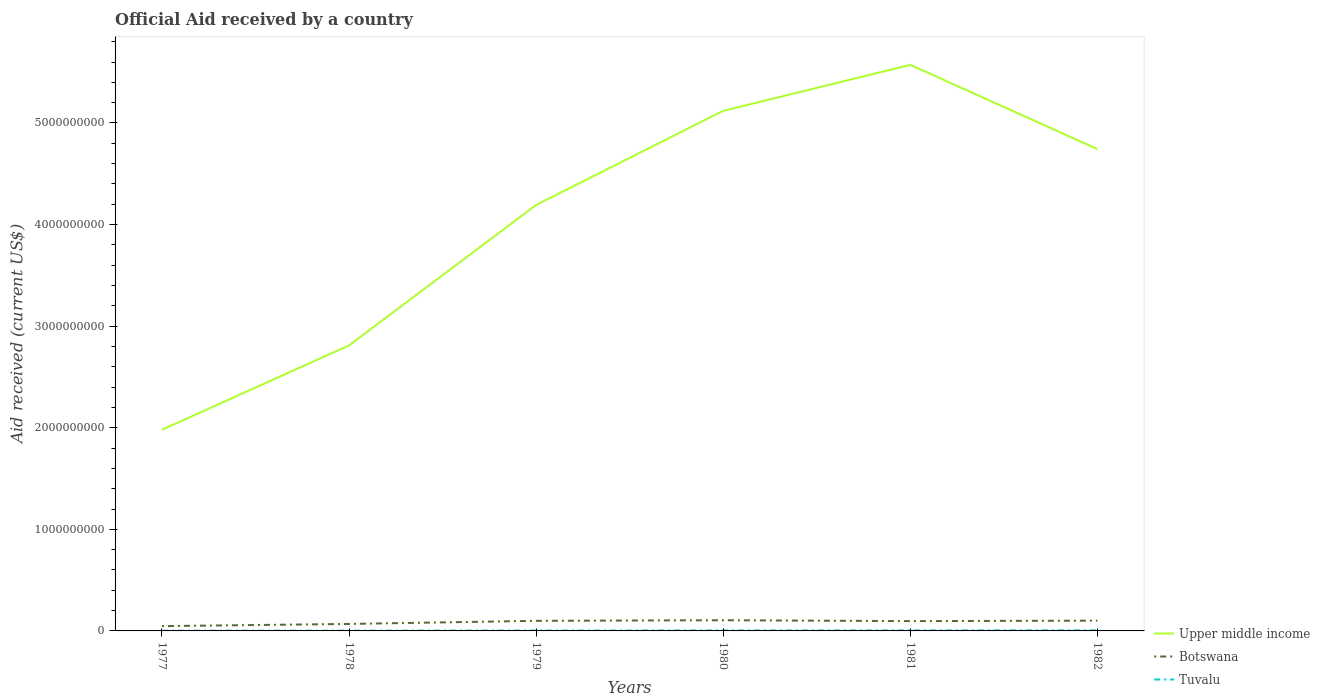How many different coloured lines are there?
Make the answer very short. 3. Does the line corresponding to Tuvalu intersect with the line corresponding to Botswana?
Offer a terse response. No. Is the number of lines equal to the number of legend labels?
Ensure brevity in your answer.  Yes. Across all years, what is the maximum net official aid received in Upper middle income?
Offer a very short reply. 1.98e+09. In which year was the net official aid received in Botswana maximum?
Your response must be concise. 1977. What is the total net official aid received in Tuvalu in the graph?
Ensure brevity in your answer.  -8.10e+05. What is the difference between the highest and the second highest net official aid received in Botswana?
Make the answer very short. 5.80e+07. What is the difference between the highest and the lowest net official aid received in Botswana?
Your response must be concise. 4. What is the difference between two consecutive major ticks on the Y-axis?
Your response must be concise. 1.00e+09. Are the values on the major ticks of Y-axis written in scientific E-notation?
Your response must be concise. No. Does the graph contain grids?
Provide a short and direct response. No. How are the legend labels stacked?
Keep it short and to the point. Vertical. What is the title of the graph?
Keep it short and to the point. Official Aid received by a country. Does "El Salvador" appear as one of the legend labels in the graph?
Your answer should be compact. No. What is the label or title of the X-axis?
Ensure brevity in your answer.  Years. What is the label or title of the Y-axis?
Provide a succinct answer. Aid received (current US$). What is the Aid received (current US$) of Upper middle income in 1977?
Offer a terse response. 1.98e+09. What is the Aid received (current US$) of Botswana in 1977?
Ensure brevity in your answer.  4.72e+07. What is the Aid received (current US$) in Tuvalu in 1977?
Offer a very short reply. 2.38e+06. What is the Aid received (current US$) in Upper middle income in 1978?
Provide a succinct answer. 2.81e+09. What is the Aid received (current US$) in Botswana in 1978?
Your answer should be very brief. 6.88e+07. What is the Aid received (current US$) in Tuvalu in 1978?
Your answer should be compact. 2.85e+06. What is the Aid received (current US$) of Upper middle income in 1979?
Provide a succinct answer. 4.19e+09. What is the Aid received (current US$) in Botswana in 1979?
Offer a very short reply. 9.94e+07. What is the Aid received (current US$) of Tuvalu in 1979?
Provide a short and direct response. 4.10e+06. What is the Aid received (current US$) in Upper middle income in 1980?
Ensure brevity in your answer.  5.12e+09. What is the Aid received (current US$) of Botswana in 1980?
Your response must be concise. 1.05e+08. What is the Aid received (current US$) in Tuvalu in 1980?
Provide a short and direct response. 4.91e+06. What is the Aid received (current US$) in Upper middle income in 1981?
Offer a very short reply. 5.57e+09. What is the Aid received (current US$) in Botswana in 1981?
Make the answer very short. 9.65e+07. What is the Aid received (current US$) of Tuvalu in 1981?
Your answer should be compact. 5.35e+06. What is the Aid received (current US$) of Upper middle income in 1982?
Your answer should be compact. 4.74e+09. What is the Aid received (current US$) of Botswana in 1982?
Provide a succinct answer. 1.01e+08. What is the Aid received (current US$) of Tuvalu in 1982?
Ensure brevity in your answer.  6.23e+06. Across all years, what is the maximum Aid received (current US$) of Upper middle income?
Your response must be concise. 5.57e+09. Across all years, what is the maximum Aid received (current US$) in Botswana?
Give a very brief answer. 1.05e+08. Across all years, what is the maximum Aid received (current US$) in Tuvalu?
Offer a very short reply. 6.23e+06. Across all years, what is the minimum Aid received (current US$) of Upper middle income?
Offer a terse response. 1.98e+09. Across all years, what is the minimum Aid received (current US$) in Botswana?
Offer a terse response. 4.72e+07. Across all years, what is the minimum Aid received (current US$) in Tuvalu?
Your answer should be compact. 2.38e+06. What is the total Aid received (current US$) of Upper middle income in the graph?
Your answer should be compact. 2.44e+1. What is the total Aid received (current US$) of Botswana in the graph?
Your answer should be compact. 5.18e+08. What is the total Aid received (current US$) of Tuvalu in the graph?
Provide a short and direct response. 2.58e+07. What is the difference between the Aid received (current US$) of Upper middle income in 1977 and that in 1978?
Offer a very short reply. -8.31e+08. What is the difference between the Aid received (current US$) in Botswana in 1977 and that in 1978?
Keep it short and to the point. -2.15e+07. What is the difference between the Aid received (current US$) of Tuvalu in 1977 and that in 1978?
Ensure brevity in your answer.  -4.70e+05. What is the difference between the Aid received (current US$) in Upper middle income in 1977 and that in 1979?
Your response must be concise. -2.21e+09. What is the difference between the Aid received (current US$) in Botswana in 1977 and that in 1979?
Keep it short and to the point. -5.22e+07. What is the difference between the Aid received (current US$) of Tuvalu in 1977 and that in 1979?
Provide a succinct answer. -1.72e+06. What is the difference between the Aid received (current US$) of Upper middle income in 1977 and that in 1980?
Your answer should be compact. -3.14e+09. What is the difference between the Aid received (current US$) of Botswana in 1977 and that in 1980?
Ensure brevity in your answer.  -5.80e+07. What is the difference between the Aid received (current US$) of Tuvalu in 1977 and that in 1980?
Ensure brevity in your answer.  -2.53e+06. What is the difference between the Aid received (current US$) of Upper middle income in 1977 and that in 1981?
Offer a terse response. -3.59e+09. What is the difference between the Aid received (current US$) in Botswana in 1977 and that in 1981?
Provide a short and direct response. -4.92e+07. What is the difference between the Aid received (current US$) in Tuvalu in 1977 and that in 1981?
Make the answer very short. -2.97e+06. What is the difference between the Aid received (current US$) of Upper middle income in 1977 and that in 1982?
Give a very brief answer. -2.76e+09. What is the difference between the Aid received (current US$) of Botswana in 1977 and that in 1982?
Offer a very short reply. -5.39e+07. What is the difference between the Aid received (current US$) of Tuvalu in 1977 and that in 1982?
Provide a succinct answer. -3.85e+06. What is the difference between the Aid received (current US$) of Upper middle income in 1978 and that in 1979?
Keep it short and to the point. -1.38e+09. What is the difference between the Aid received (current US$) in Botswana in 1978 and that in 1979?
Keep it short and to the point. -3.06e+07. What is the difference between the Aid received (current US$) in Tuvalu in 1978 and that in 1979?
Your answer should be very brief. -1.25e+06. What is the difference between the Aid received (current US$) of Upper middle income in 1978 and that in 1980?
Keep it short and to the point. -2.31e+09. What is the difference between the Aid received (current US$) in Botswana in 1978 and that in 1980?
Your answer should be very brief. -3.65e+07. What is the difference between the Aid received (current US$) of Tuvalu in 1978 and that in 1980?
Your answer should be compact. -2.06e+06. What is the difference between the Aid received (current US$) of Upper middle income in 1978 and that in 1981?
Provide a short and direct response. -2.76e+09. What is the difference between the Aid received (current US$) in Botswana in 1978 and that in 1981?
Keep it short and to the point. -2.77e+07. What is the difference between the Aid received (current US$) in Tuvalu in 1978 and that in 1981?
Offer a very short reply. -2.50e+06. What is the difference between the Aid received (current US$) of Upper middle income in 1978 and that in 1982?
Give a very brief answer. -1.93e+09. What is the difference between the Aid received (current US$) in Botswana in 1978 and that in 1982?
Keep it short and to the point. -3.24e+07. What is the difference between the Aid received (current US$) of Tuvalu in 1978 and that in 1982?
Your response must be concise. -3.38e+06. What is the difference between the Aid received (current US$) in Upper middle income in 1979 and that in 1980?
Offer a very short reply. -9.26e+08. What is the difference between the Aid received (current US$) of Botswana in 1979 and that in 1980?
Ensure brevity in your answer.  -5.86e+06. What is the difference between the Aid received (current US$) in Tuvalu in 1979 and that in 1980?
Offer a terse response. -8.10e+05. What is the difference between the Aid received (current US$) of Upper middle income in 1979 and that in 1981?
Keep it short and to the point. -1.38e+09. What is the difference between the Aid received (current US$) of Botswana in 1979 and that in 1981?
Your answer should be compact. 2.94e+06. What is the difference between the Aid received (current US$) in Tuvalu in 1979 and that in 1981?
Your response must be concise. -1.25e+06. What is the difference between the Aid received (current US$) of Upper middle income in 1979 and that in 1982?
Provide a short and direct response. -5.50e+08. What is the difference between the Aid received (current US$) of Botswana in 1979 and that in 1982?
Keep it short and to the point. -1.73e+06. What is the difference between the Aid received (current US$) in Tuvalu in 1979 and that in 1982?
Make the answer very short. -2.13e+06. What is the difference between the Aid received (current US$) in Upper middle income in 1980 and that in 1981?
Ensure brevity in your answer.  -4.53e+08. What is the difference between the Aid received (current US$) of Botswana in 1980 and that in 1981?
Make the answer very short. 8.80e+06. What is the difference between the Aid received (current US$) in Tuvalu in 1980 and that in 1981?
Your answer should be compact. -4.40e+05. What is the difference between the Aid received (current US$) of Upper middle income in 1980 and that in 1982?
Your response must be concise. 3.76e+08. What is the difference between the Aid received (current US$) of Botswana in 1980 and that in 1982?
Your response must be concise. 4.13e+06. What is the difference between the Aid received (current US$) of Tuvalu in 1980 and that in 1982?
Offer a terse response. -1.32e+06. What is the difference between the Aid received (current US$) in Upper middle income in 1981 and that in 1982?
Give a very brief answer. 8.29e+08. What is the difference between the Aid received (current US$) of Botswana in 1981 and that in 1982?
Keep it short and to the point. -4.67e+06. What is the difference between the Aid received (current US$) in Tuvalu in 1981 and that in 1982?
Keep it short and to the point. -8.80e+05. What is the difference between the Aid received (current US$) of Upper middle income in 1977 and the Aid received (current US$) of Botswana in 1978?
Ensure brevity in your answer.  1.91e+09. What is the difference between the Aid received (current US$) in Upper middle income in 1977 and the Aid received (current US$) in Tuvalu in 1978?
Provide a succinct answer. 1.98e+09. What is the difference between the Aid received (current US$) of Botswana in 1977 and the Aid received (current US$) of Tuvalu in 1978?
Your answer should be very brief. 4.44e+07. What is the difference between the Aid received (current US$) in Upper middle income in 1977 and the Aid received (current US$) in Botswana in 1979?
Offer a terse response. 1.88e+09. What is the difference between the Aid received (current US$) in Upper middle income in 1977 and the Aid received (current US$) in Tuvalu in 1979?
Provide a short and direct response. 1.98e+09. What is the difference between the Aid received (current US$) of Botswana in 1977 and the Aid received (current US$) of Tuvalu in 1979?
Give a very brief answer. 4.32e+07. What is the difference between the Aid received (current US$) in Upper middle income in 1977 and the Aid received (current US$) in Botswana in 1980?
Keep it short and to the point. 1.87e+09. What is the difference between the Aid received (current US$) in Upper middle income in 1977 and the Aid received (current US$) in Tuvalu in 1980?
Offer a very short reply. 1.98e+09. What is the difference between the Aid received (current US$) in Botswana in 1977 and the Aid received (current US$) in Tuvalu in 1980?
Your answer should be very brief. 4.23e+07. What is the difference between the Aid received (current US$) of Upper middle income in 1977 and the Aid received (current US$) of Botswana in 1981?
Make the answer very short. 1.88e+09. What is the difference between the Aid received (current US$) of Upper middle income in 1977 and the Aid received (current US$) of Tuvalu in 1981?
Make the answer very short. 1.97e+09. What is the difference between the Aid received (current US$) in Botswana in 1977 and the Aid received (current US$) in Tuvalu in 1981?
Provide a short and direct response. 4.19e+07. What is the difference between the Aid received (current US$) in Upper middle income in 1977 and the Aid received (current US$) in Botswana in 1982?
Ensure brevity in your answer.  1.88e+09. What is the difference between the Aid received (current US$) of Upper middle income in 1977 and the Aid received (current US$) of Tuvalu in 1982?
Offer a very short reply. 1.97e+09. What is the difference between the Aid received (current US$) of Botswana in 1977 and the Aid received (current US$) of Tuvalu in 1982?
Offer a terse response. 4.10e+07. What is the difference between the Aid received (current US$) of Upper middle income in 1978 and the Aid received (current US$) of Botswana in 1979?
Provide a succinct answer. 2.71e+09. What is the difference between the Aid received (current US$) of Upper middle income in 1978 and the Aid received (current US$) of Tuvalu in 1979?
Your answer should be compact. 2.81e+09. What is the difference between the Aid received (current US$) of Botswana in 1978 and the Aid received (current US$) of Tuvalu in 1979?
Ensure brevity in your answer.  6.47e+07. What is the difference between the Aid received (current US$) in Upper middle income in 1978 and the Aid received (current US$) in Botswana in 1980?
Make the answer very short. 2.71e+09. What is the difference between the Aid received (current US$) of Upper middle income in 1978 and the Aid received (current US$) of Tuvalu in 1980?
Provide a succinct answer. 2.81e+09. What is the difference between the Aid received (current US$) of Botswana in 1978 and the Aid received (current US$) of Tuvalu in 1980?
Keep it short and to the point. 6.39e+07. What is the difference between the Aid received (current US$) of Upper middle income in 1978 and the Aid received (current US$) of Botswana in 1981?
Make the answer very short. 2.71e+09. What is the difference between the Aid received (current US$) of Upper middle income in 1978 and the Aid received (current US$) of Tuvalu in 1981?
Provide a short and direct response. 2.81e+09. What is the difference between the Aid received (current US$) of Botswana in 1978 and the Aid received (current US$) of Tuvalu in 1981?
Your answer should be compact. 6.34e+07. What is the difference between the Aid received (current US$) in Upper middle income in 1978 and the Aid received (current US$) in Botswana in 1982?
Your answer should be compact. 2.71e+09. What is the difference between the Aid received (current US$) in Upper middle income in 1978 and the Aid received (current US$) in Tuvalu in 1982?
Your answer should be compact. 2.80e+09. What is the difference between the Aid received (current US$) in Botswana in 1978 and the Aid received (current US$) in Tuvalu in 1982?
Ensure brevity in your answer.  6.25e+07. What is the difference between the Aid received (current US$) in Upper middle income in 1979 and the Aid received (current US$) in Botswana in 1980?
Give a very brief answer. 4.09e+09. What is the difference between the Aid received (current US$) of Upper middle income in 1979 and the Aid received (current US$) of Tuvalu in 1980?
Your answer should be very brief. 4.19e+09. What is the difference between the Aid received (current US$) of Botswana in 1979 and the Aid received (current US$) of Tuvalu in 1980?
Your answer should be very brief. 9.45e+07. What is the difference between the Aid received (current US$) of Upper middle income in 1979 and the Aid received (current US$) of Botswana in 1981?
Offer a terse response. 4.10e+09. What is the difference between the Aid received (current US$) of Upper middle income in 1979 and the Aid received (current US$) of Tuvalu in 1981?
Provide a succinct answer. 4.19e+09. What is the difference between the Aid received (current US$) of Botswana in 1979 and the Aid received (current US$) of Tuvalu in 1981?
Provide a short and direct response. 9.41e+07. What is the difference between the Aid received (current US$) of Upper middle income in 1979 and the Aid received (current US$) of Botswana in 1982?
Provide a short and direct response. 4.09e+09. What is the difference between the Aid received (current US$) of Upper middle income in 1979 and the Aid received (current US$) of Tuvalu in 1982?
Keep it short and to the point. 4.19e+09. What is the difference between the Aid received (current US$) of Botswana in 1979 and the Aid received (current US$) of Tuvalu in 1982?
Your answer should be compact. 9.32e+07. What is the difference between the Aid received (current US$) of Upper middle income in 1980 and the Aid received (current US$) of Botswana in 1981?
Make the answer very short. 5.02e+09. What is the difference between the Aid received (current US$) of Upper middle income in 1980 and the Aid received (current US$) of Tuvalu in 1981?
Your answer should be very brief. 5.11e+09. What is the difference between the Aid received (current US$) of Botswana in 1980 and the Aid received (current US$) of Tuvalu in 1981?
Ensure brevity in your answer.  9.99e+07. What is the difference between the Aid received (current US$) in Upper middle income in 1980 and the Aid received (current US$) in Botswana in 1982?
Provide a short and direct response. 5.02e+09. What is the difference between the Aid received (current US$) in Upper middle income in 1980 and the Aid received (current US$) in Tuvalu in 1982?
Keep it short and to the point. 5.11e+09. What is the difference between the Aid received (current US$) in Botswana in 1980 and the Aid received (current US$) in Tuvalu in 1982?
Keep it short and to the point. 9.90e+07. What is the difference between the Aid received (current US$) of Upper middle income in 1981 and the Aid received (current US$) of Botswana in 1982?
Keep it short and to the point. 5.47e+09. What is the difference between the Aid received (current US$) of Upper middle income in 1981 and the Aid received (current US$) of Tuvalu in 1982?
Ensure brevity in your answer.  5.57e+09. What is the difference between the Aid received (current US$) of Botswana in 1981 and the Aid received (current US$) of Tuvalu in 1982?
Your answer should be compact. 9.02e+07. What is the average Aid received (current US$) in Upper middle income per year?
Make the answer very short. 4.07e+09. What is the average Aid received (current US$) of Botswana per year?
Give a very brief answer. 8.64e+07. What is the average Aid received (current US$) in Tuvalu per year?
Provide a succinct answer. 4.30e+06. In the year 1977, what is the difference between the Aid received (current US$) in Upper middle income and Aid received (current US$) in Botswana?
Give a very brief answer. 1.93e+09. In the year 1977, what is the difference between the Aid received (current US$) of Upper middle income and Aid received (current US$) of Tuvalu?
Offer a terse response. 1.98e+09. In the year 1977, what is the difference between the Aid received (current US$) of Botswana and Aid received (current US$) of Tuvalu?
Make the answer very short. 4.49e+07. In the year 1978, what is the difference between the Aid received (current US$) in Upper middle income and Aid received (current US$) in Botswana?
Ensure brevity in your answer.  2.74e+09. In the year 1978, what is the difference between the Aid received (current US$) of Upper middle income and Aid received (current US$) of Tuvalu?
Ensure brevity in your answer.  2.81e+09. In the year 1978, what is the difference between the Aid received (current US$) in Botswana and Aid received (current US$) in Tuvalu?
Offer a terse response. 6.59e+07. In the year 1979, what is the difference between the Aid received (current US$) in Upper middle income and Aid received (current US$) in Botswana?
Your answer should be compact. 4.09e+09. In the year 1979, what is the difference between the Aid received (current US$) in Upper middle income and Aid received (current US$) in Tuvalu?
Your answer should be very brief. 4.19e+09. In the year 1979, what is the difference between the Aid received (current US$) of Botswana and Aid received (current US$) of Tuvalu?
Make the answer very short. 9.53e+07. In the year 1980, what is the difference between the Aid received (current US$) in Upper middle income and Aid received (current US$) in Botswana?
Your response must be concise. 5.01e+09. In the year 1980, what is the difference between the Aid received (current US$) in Upper middle income and Aid received (current US$) in Tuvalu?
Keep it short and to the point. 5.11e+09. In the year 1980, what is the difference between the Aid received (current US$) in Botswana and Aid received (current US$) in Tuvalu?
Your response must be concise. 1.00e+08. In the year 1981, what is the difference between the Aid received (current US$) in Upper middle income and Aid received (current US$) in Botswana?
Ensure brevity in your answer.  5.48e+09. In the year 1981, what is the difference between the Aid received (current US$) in Upper middle income and Aid received (current US$) in Tuvalu?
Offer a very short reply. 5.57e+09. In the year 1981, what is the difference between the Aid received (current US$) of Botswana and Aid received (current US$) of Tuvalu?
Offer a very short reply. 9.11e+07. In the year 1982, what is the difference between the Aid received (current US$) of Upper middle income and Aid received (current US$) of Botswana?
Provide a short and direct response. 4.64e+09. In the year 1982, what is the difference between the Aid received (current US$) of Upper middle income and Aid received (current US$) of Tuvalu?
Ensure brevity in your answer.  4.74e+09. In the year 1982, what is the difference between the Aid received (current US$) in Botswana and Aid received (current US$) in Tuvalu?
Offer a very short reply. 9.49e+07. What is the ratio of the Aid received (current US$) in Upper middle income in 1977 to that in 1978?
Offer a very short reply. 0.7. What is the ratio of the Aid received (current US$) in Botswana in 1977 to that in 1978?
Your answer should be compact. 0.69. What is the ratio of the Aid received (current US$) of Tuvalu in 1977 to that in 1978?
Give a very brief answer. 0.84. What is the ratio of the Aid received (current US$) in Upper middle income in 1977 to that in 1979?
Offer a very short reply. 0.47. What is the ratio of the Aid received (current US$) in Botswana in 1977 to that in 1979?
Give a very brief answer. 0.48. What is the ratio of the Aid received (current US$) in Tuvalu in 1977 to that in 1979?
Your response must be concise. 0.58. What is the ratio of the Aid received (current US$) in Upper middle income in 1977 to that in 1980?
Offer a very short reply. 0.39. What is the ratio of the Aid received (current US$) in Botswana in 1977 to that in 1980?
Your answer should be compact. 0.45. What is the ratio of the Aid received (current US$) of Tuvalu in 1977 to that in 1980?
Offer a terse response. 0.48. What is the ratio of the Aid received (current US$) of Upper middle income in 1977 to that in 1981?
Offer a very short reply. 0.36. What is the ratio of the Aid received (current US$) in Botswana in 1977 to that in 1981?
Give a very brief answer. 0.49. What is the ratio of the Aid received (current US$) of Tuvalu in 1977 to that in 1981?
Offer a terse response. 0.44. What is the ratio of the Aid received (current US$) in Upper middle income in 1977 to that in 1982?
Offer a terse response. 0.42. What is the ratio of the Aid received (current US$) of Botswana in 1977 to that in 1982?
Keep it short and to the point. 0.47. What is the ratio of the Aid received (current US$) in Tuvalu in 1977 to that in 1982?
Your response must be concise. 0.38. What is the ratio of the Aid received (current US$) of Upper middle income in 1978 to that in 1979?
Make the answer very short. 0.67. What is the ratio of the Aid received (current US$) of Botswana in 1978 to that in 1979?
Offer a very short reply. 0.69. What is the ratio of the Aid received (current US$) of Tuvalu in 1978 to that in 1979?
Your answer should be very brief. 0.7. What is the ratio of the Aid received (current US$) of Upper middle income in 1978 to that in 1980?
Keep it short and to the point. 0.55. What is the ratio of the Aid received (current US$) of Botswana in 1978 to that in 1980?
Offer a very short reply. 0.65. What is the ratio of the Aid received (current US$) of Tuvalu in 1978 to that in 1980?
Offer a very short reply. 0.58. What is the ratio of the Aid received (current US$) of Upper middle income in 1978 to that in 1981?
Give a very brief answer. 0.5. What is the ratio of the Aid received (current US$) of Botswana in 1978 to that in 1981?
Provide a short and direct response. 0.71. What is the ratio of the Aid received (current US$) in Tuvalu in 1978 to that in 1981?
Your answer should be compact. 0.53. What is the ratio of the Aid received (current US$) in Upper middle income in 1978 to that in 1982?
Make the answer very short. 0.59. What is the ratio of the Aid received (current US$) in Botswana in 1978 to that in 1982?
Give a very brief answer. 0.68. What is the ratio of the Aid received (current US$) in Tuvalu in 1978 to that in 1982?
Provide a short and direct response. 0.46. What is the ratio of the Aid received (current US$) in Upper middle income in 1979 to that in 1980?
Offer a terse response. 0.82. What is the ratio of the Aid received (current US$) of Botswana in 1979 to that in 1980?
Your response must be concise. 0.94. What is the ratio of the Aid received (current US$) in Tuvalu in 1979 to that in 1980?
Your answer should be compact. 0.83. What is the ratio of the Aid received (current US$) in Upper middle income in 1979 to that in 1981?
Give a very brief answer. 0.75. What is the ratio of the Aid received (current US$) of Botswana in 1979 to that in 1981?
Provide a succinct answer. 1.03. What is the ratio of the Aid received (current US$) of Tuvalu in 1979 to that in 1981?
Offer a very short reply. 0.77. What is the ratio of the Aid received (current US$) of Upper middle income in 1979 to that in 1982?
Your answer should be compact. 0.88. What is the ratio of the Aid received (current US$) of Botswana in 1979 to that in 1982?
Your response must be concise. 0.98. What is the ratio of the Aid received (current US$) in Tuvalu in 1979 to that in 1982?
Make the answer very short. 0.66. What is the ratio of the Aid received (current US$) of Upper middle income in 1980 to that in 1981?
Your answer should be compact. 0.92. What is the ratio of the Aid received (current US$) of Botswana in 1980 to that in 1981?
Your response must be concise. 1.09. What is the ratio of the Aid received (current US$) in Tuvalu in 1980 to that in 1981?
Your response must be concise. 0.92. What is the ratio of the Aid received (current US$) in Upper middle income in 1980 to that in 1982?
Offer a terse response. 1.08. What is the ratio of the Aid received (current US$) in Botswana in 1980 to that in 1982?
Provide a succinct answer. 1.04. What is the ratio of the Aid received (current US$) of Tuvalu in 1980 to that in 1982?
Your answer should be very brief. 0.79. What is the ratio of the Aid received (current US$) of Upper middle income in 1981 to that in 1982?
Make the answer very short. 1.17. What is the ratio of the Aid received (current US$) of Botswana in 1981 to that in 1982?
Your answer should be compact. 0.95. What is the ratio of the Aid received (current US$) in Tuvalu in 1981 to that in 1982?
Your response must be concise. 0.86. What is the difference between the highest and the second highest Aid received (current US$) in Upper middle income?
Your answer should be compact. 4.53e+08. What is the difference between the highest and the second highest Aid received (current US$) of Botswana?
Ensure brevity in your answer.  4.13e+06. What is the difference between the highest and the second highest Aid received (current US$) in Tuvalu?
Your response must be concise. 8.80e+05. What is the difference between the highest and the lowest Aid received (current US$) in Upper middle income?
Ensure brevity in your answer.  3.59e+09. What is the difference between the highest and the lowest Aid received (current US$) in Botswana?
Provide a succinct answer. 5.80e+07. What is the difference between the highest and the lowest Aid received (current US$) in Tuvalu?
Offer a very short reply. 3.85e+06. 